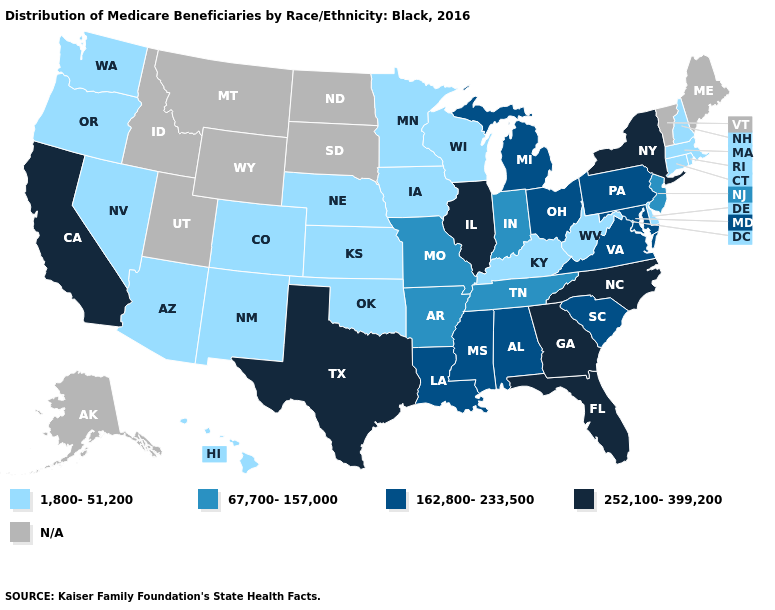Among the states that border Vermont , does New York have the highest value?
Give a very brief answer. Yes. Name the states that have a value in the range 1,800-51,200?
Short answer required. Arizona, Colorado, Connecticut, Delaware, Hawaii, Iowa, Kansas, Kentucky, Massachusetts, Minnesota, Nebraska, Nevada, New Hampshire, New Mexico, Oklahoma, Oregon, Rhode Island, Washington, West Virginia, Wisconsin. What is the value of North Carolina?
Quick response, please. 252,100-399,200. What is the value of Maryland?
Write a very short answer. 162,800-233,500. What is the value of Vermont?
Keep it brief. N/A. Is the legend a continuous bar?
Short answer required. No. Among the states that border Alabama , does Mississippi have the highest value?
Quick response, please. No. What is the value of Kansas?
Short answer required. 1,800-51,200. Name the states that have a value in the range 1,800-51,200?
Quick response, please. Arizona, Colorado, Connecticut, Delaware, Hawaii, Iowa, Kansas, Kentucky, Massachusetts, Minnesota, Nebraska, Nevada, New Hampshire, New Mexico, Oklahoma, Oregon, Rhode Island, Washington, West Virginia, Wisconsin. Does the map have missing data?
Write a very short answer. Yes. Name the states that have a value in the range 252,100-399,200?
Write a very short answer. California, Florida, Georgia, Illinois, New York, North Carolina, Texas. What is the value of Missouri?
Be succinct. 67,700-157,000. Which states hav the highest value in the South?
Answer briefly. Florida, Georgia, North Carolina, Texas. What is the value of North Carolina?
Be succinct. 252,100-399,200. Which states hav the highest value in the MidWest?
Give a very brief answer. Illinois. 